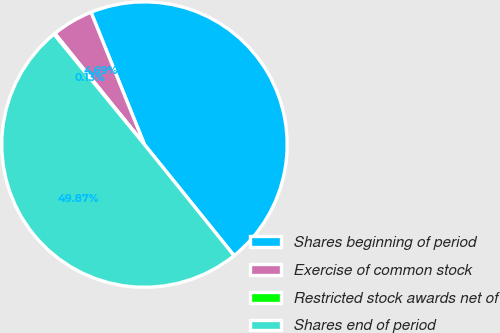<chart> <loc_0><loc_0><loc_500><loc_500><pie_chart><fcel>Shares beginning of period<fcel>Exercise of common stock<fcel>Restricted stock awards net of<fcel>Shares end of period<nl><fcel>45.31%<fcel>4.69%<fcel>0.13%<fcel>49.87%<nl></chart> 